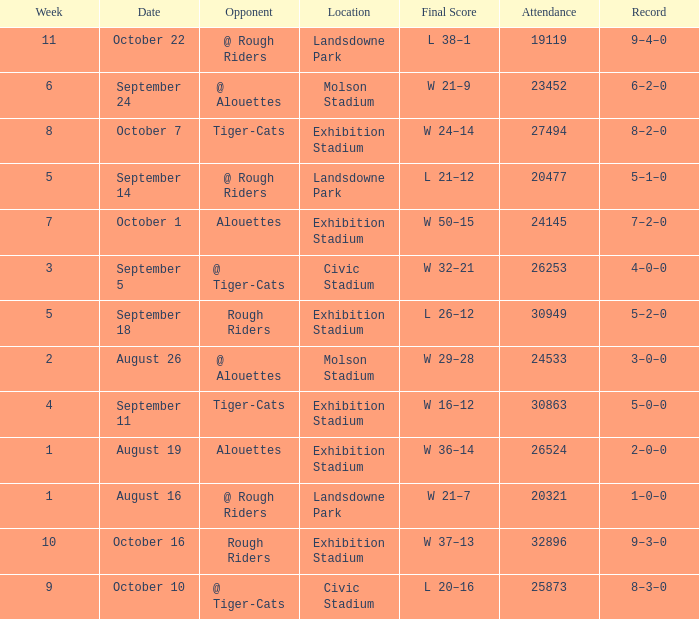How many values for attendance on the date of September 5? 1.0. 